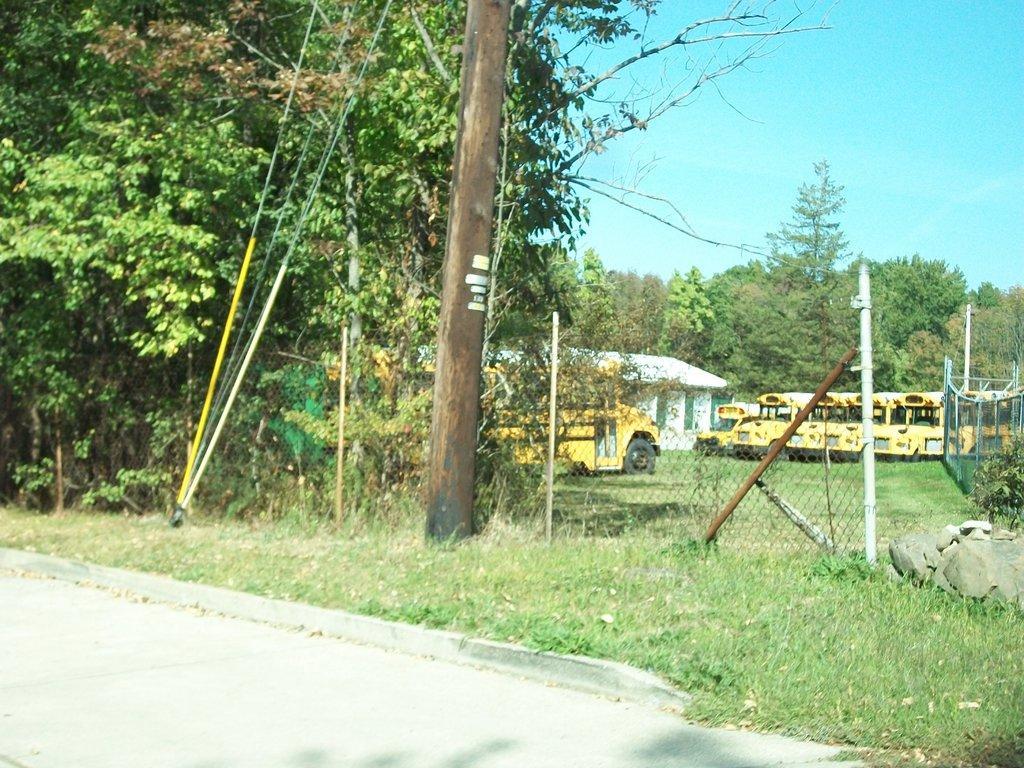In one or two sentences, can you explain what this image depicts? In this picture there are buses and there is a building behind the fence and there are trees. In the foreground there is a pole and there are wires. At the top there is sky. At the bottom there is grass and there is a road. 